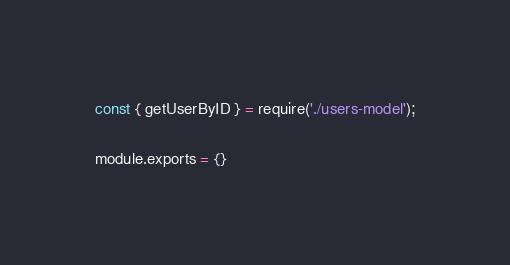<code> <loc_0><loc_0><loc_500><loc_500><_JavaScript_>const { getUserByID } = require('./users-model');

module.exports = {}</code> 